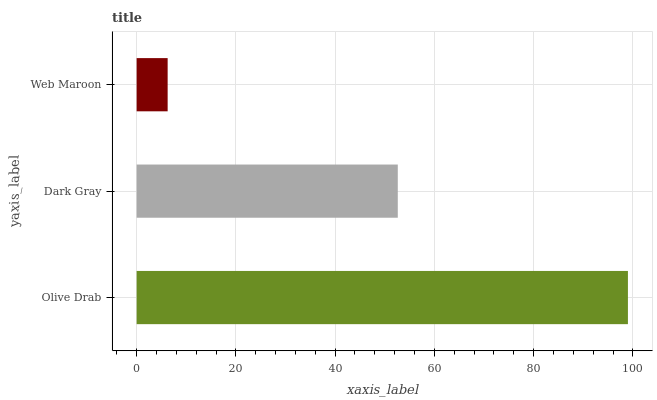Is Web Maroon the minimum?
Answer yes or no. Yes. Is Olive Drab the maximum?
Answer yes or no. Yes. Is Dark Gray the minimum?
Answer yes or no. No. Is Dark Gray the maximum?
Answer yes or no. No. Is Olive Drab greater than Dark Gray?
Answer yes or no. Yes. Is Dark Gray less than Olive Drab?
Answer yes or no. Yes. Is Dark Gray greater than Olive Drab?
Answer yes or no. No. Is Olive Drab less than Dark Gray?
Answer yes or no. No. Is Dark Gray the high median?
Answer yes or no. Yes. Is Dark Gray the low median?
Answer yes or no. Yes. Is Olive Drab the high median?
Answer yes or no. No. Is Web Maroon the low median?
Answer yes or no. No. 